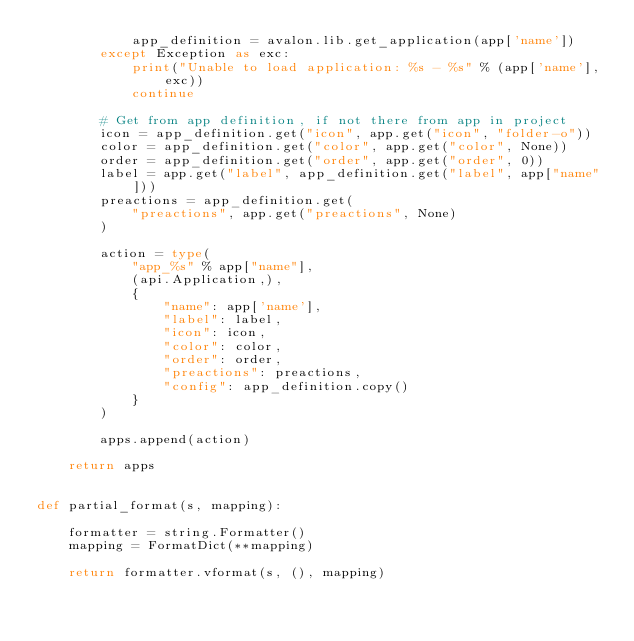Convert code to text. <code><loc_0><loc_0><loc_500><loc_500><_Python_>            app_definition = avalon.lib.get_application(app['name'])
        except Exception as exc:
            print("Unable to load application: %s - %s" % (app['name'], exc))
            continue

        # Get from app definition, if not there from app in project
        icon = app_definition.get("icon", app.get("icon", "folder-o"))
        color = app_definition.get("color", app.get("color", None))
        order = app_definition.get("order", app.get("order", 0))
        label = app.get("label", app_definition.get("label", app["name"]))
        preactions = app_definition.get(
            "preactions", app.get("preactions", None)
        )

        action = type(
            "app_%s" % app["name"],
            (api.Application,),
            {
                "name": app['name'],
                "label": label,
                "icon": icon,
                "color": color,
                "order": order,
                "preactions": preactions,
                "config": app_definition.copy()
            }
        )

        apps.append(action)

    return apps


def partial_format(s, mapping):

    formatter = string.Formatter()
    mapping = FormatDict(**mapping)

    return formatter.vformat(s, (), mapping)
</code> 